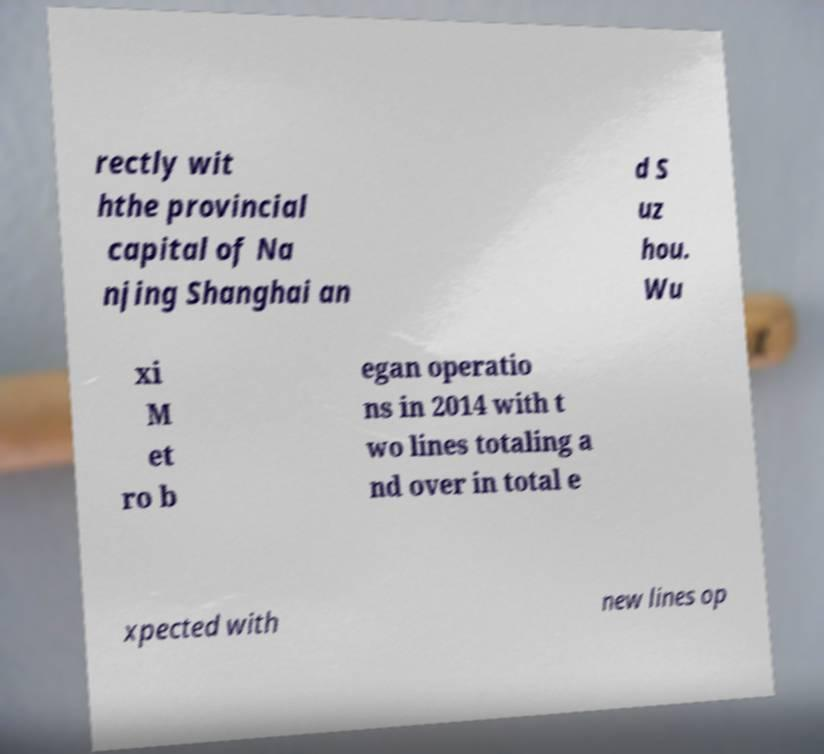Could you extract and type out the text from this image? rectly wit hthe provincial capital of Na njing Shanghai an d S uz hou. Wu xi M et ro b egan operatio ns in 2014 with t wo lines totaling a nd over in total e xpected with new lines op 